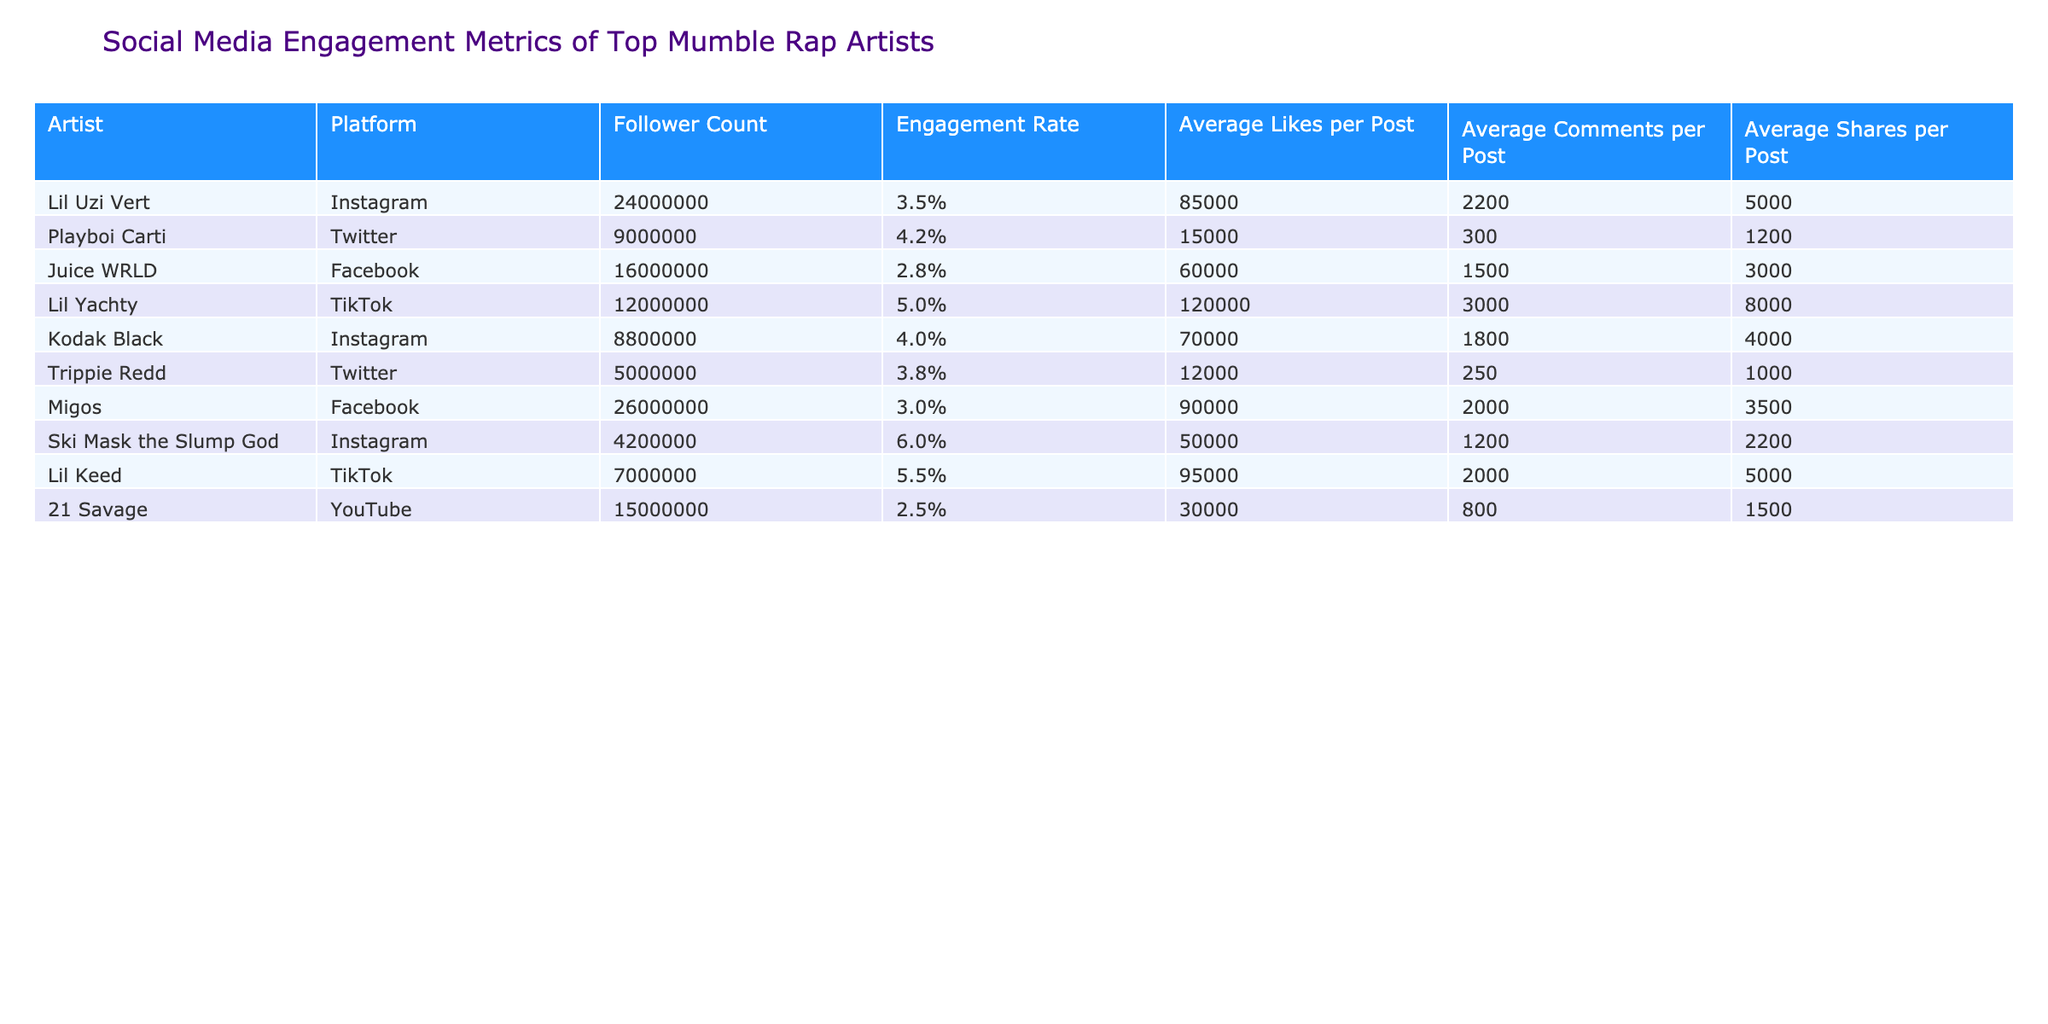What is the engagement rate of Lil Uzi Vert on Instagram? The engagement rate for Lil Uzi Vert can be found in the table, which shows it as 3.5% in the corresponding row for Instagram.
Answer: 3.5% Which artist has the highest average likes per post on TikTok? By examining the TikTok entries in the table, Lil Yachty has the highest average likes per post, listed as 120,000.
Answer: Lil Yachty What is the difference in follower count between Migos and Kodak Black? Migos has a follower count of 26,000,000 and Kodak Black has 8,800,000. The difference can be calculated as 26,000,000 - 8,800,000 = 17,200,000.
Answer: 17,200,000 Is Lil Keed's engagement rate higher than 5%? Looking at Lil Keed's row in the table, his engagement rate is listed as 5.5%, which is indeed higher than 5%.
Answer: Yes What is the average engagement rate of all the artists listed in the table? First, we gather the engagement rates: 3.5, 4.2, 2.8, 5.0, 4.0, 3.8, 3.0, 6.0, 5.5, and 2.5. Adding these gives a total of 36.3%. To find the average, we divide this by 10 (the number of artists), resulting in an average engagement rate of 3.63%.
Answer: 3.63% Which platform has the lowest average comments per post among the listed artists? The average comments per post for each artist and platform are: 2200 (Instagram), 300 (Twitter), 1500 (Facebook), 3000 (TikTok), 1800 (Instagram), 250 (Twitter), 2000 (Facebook), 1200 (Instagram), 2000 (TikTok), and 800 (YouTube). The lowest is 250 for Trippie Redd on Twitter.
Answer: Twitter How many total shares per post does Juice WRLD have? The table indicates that Juice WRLD has an average of 3,000 shares per post on Facebook, which is the only platform for him listed here. Thus, the answer directly reflects that individual metric.
Answer: 3,000 Which artist has the lowest follower count on Instagram? In the table, Ski Mask the Slump God has the lowest follower count among the listed artists on Instagram with 4,200,000 followers.
Answer: Ski Mask the Slump God 